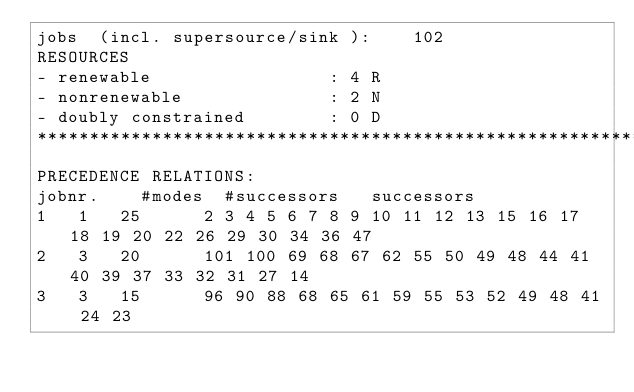Convert code to text. <code><loc_0><loc_0><loc_500><loc_500><_ObjectiveC_>jobs  (incl. supersource/sink ):	102
RESOURCES
- renewable                 : 4 R
- nonrenewable              : 2 N
- doubly constrained        : 0 D
************************************************************************
PRECEDENCE RELATIONS:
jobnr.    #modes  #successors   successors
1	1	25		2 3 4 5 6 7 8 9 10 11 12 13 15 16 17 18 19 20 22 26 29 30 34 36 47 
2	3	20		101 100 69 68 67 62 55 50 49 48 44 41 40 39 37 33 32 31 27 14 
3	3	15		96 90 88 68 65 61 59 55 53 52 49 48 41 24 23 </code> 